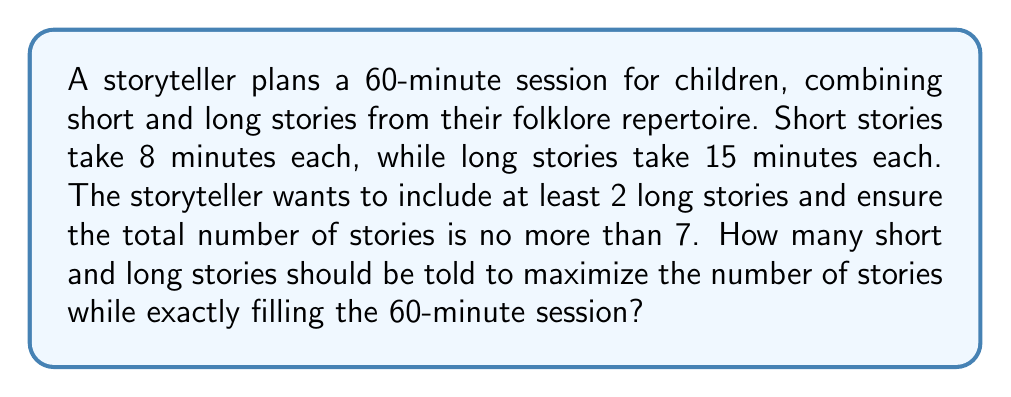Give your solution to this math problem. Let's approach this step-by-step using a system of equations:

1) Let $x$ be the number of short stories and $y$ be the number of long stories.

2) We can form two equations based on the given information:
   - Time constraint: $8x + 15y = 60$
   - Total stories constraint: $x + y \leq 7$

3) We also know that $y \geq 2$ (at least 2 long stories) and both $x$ and $y$ must be non-negative integers.

4) Let's solve the time constraint equation for $x$:
   $8x + 15y = 60$
   $8x = 60 - 15y$
   $x = \frac{60 - 15y}{8} = \frac{15 - \frac{15y}{2}}{2}$

5) Since $x$ must be an integer, $\frac{15y}{2}$ must be an odd number. This is only possible when $y$ is even.

6) Given $y \geq 2$ and $y$ is even, the possible values for $y$ are 2, 4, and 6.

7) Let's check each case:
   - If $y = 2$: $x = \frac{15 - 15}{2} = 0$, total stories = 2
   - If $y = 4$: $x = \frac{15 - 30}{2} = -7.5$ (invalid)
   - If $y = 6$: $x = \frac{15 - 45}{2} = -15$ (invalid)

8) The only valid solution is $y = 2$ and $x = 3$, which satisfies all constraints:
   - Time: $8(3) + 15(2) = 24 + 30 = 60$ minutes
   - Total stories: $3 + 2 = 5 \leq 7$
   - At least 2 long stories: $2 \geq 2$

Therefore, the storyteller should tell 3 short stories and 2 long stories.
Answer: 3 short stories and 2 long stories 